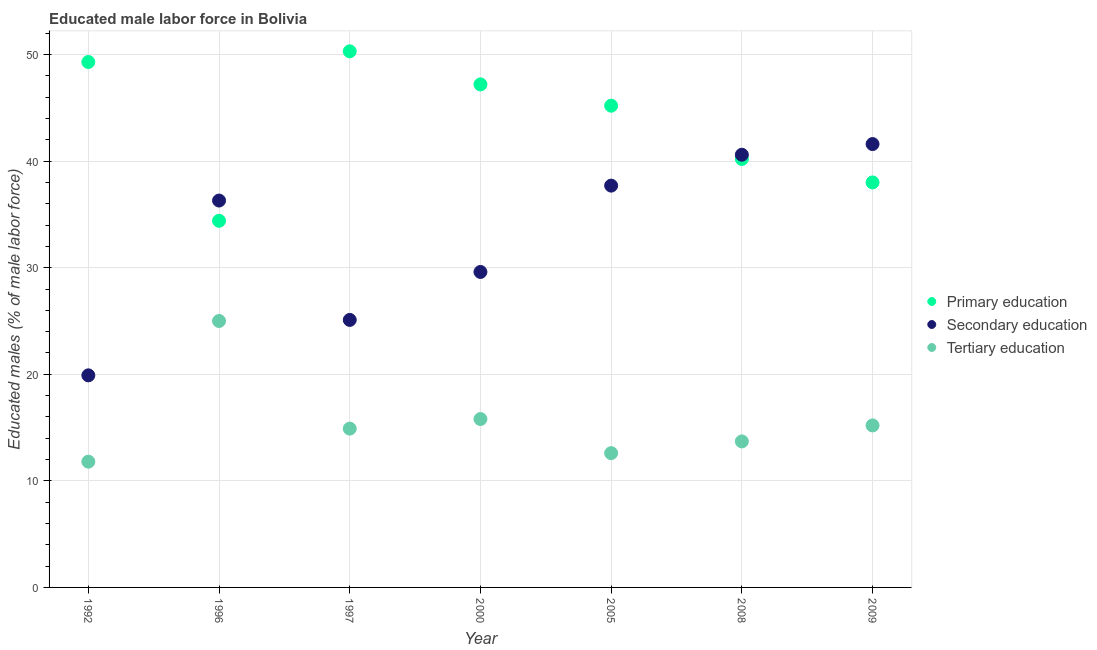How many different coloured dotlines are there?
Your answer should be very brief. 3. Is the number of dotlines equal to the number of legend labels?
Give a very brief answer. Yes. What is the percentage of male labor force who received primary education in 1992?
Your answer should be very brief. 49.3. Across all years, what is the maximum percentage of male labor force who received primary education?
Ensure brevity in your answer.  50.3. Across all years, what is the minimum percentage of male labor force who received tertiary education?
Make the answer very short. 11.8. In which year was the percentage of male labor force who received tertiary education minimum?
Offer a terse response. 1992. What is the total percentage of male labor force who received secondary education in the graph?
Provide a succinct answer. 230.8. What is the difference between the percentage of male labor force who received primary education in 1992 and that in 1996?
Give a very brief answer. 14.9. What is the difference between the percentage of male labor force who received tertiary education in 2000 and the percentage of male labor force who received primary education in 2008?
Offer a very short reply. -24.4. What is the average percentage of male labor force who received secondary education per year?
Make the answer very short. 32.97. In the year 2009, what is the difference between the percentage of male labor force who received secondary education and percentage of male labor force who received tertiary education?
Your response must be concise. 26.4. What is the ratio of the percentage of male labor force who received secondary education in 1996 to that in 2008?
Your response must be concise. 0.89. Is the percentage of male labor force who received secondary education in 1992 less than that in 2009?
Ensure brevity in your answer.  Yes. What is the difference between the highest and the second highest percentage of male labor force who received tertiary education?
Your answer should be compact. 9.2. What is the difference between the highest and the lowest percentage of male labor force who received tertiary education?
Ensure brevity in your answer.  13.2. In how many years, is the percentage of male labor force who received primary education greater than the average percentage of male labor force who received primary education taken over all years?
Give a very brief answer. 4. Is the percentage of male labor force who received primary education strictly greater than the percentage of male labor force who received secondary education over the years?
Your answer should be compact. No. Are the values on the major ticks of Y-axis written in scientific E-notation?
Offer a terse response. No. Does the graph contain any zero values?
Give a very brief answer. No. What is the title of the graph?
Give a very brief answer. Educated male labor force in Bolivia. What is the label or title of the Y-axis?
Provide a succinct answer. Educated males (% of male labor force). What is the Educated males (% of male labor force) of Primary education in 1992?
Provide a short and direct response. 49.3. What is the Educated males (% of male labor force) in Secondary education in 1992?
Offer a terse response. 19.9. What is the Educated males (% of male labor force) of Tertiary education in 1992?
Offer a terse response. 11.8. What is the Educated males (% of male labor force) of Primary education in 1996?
Your answer should be very brief. 34.4. What is the Educated males (% of male labor force) of Secondary education in 1996?
Provide a succinct answer. 36.3. What is the Educated males (% of male labor force) in Tertiary education in 1996?
Ensure brevity in your answer.  25. What is the Educated males (% of male labor force) in Primary education in 1997?
Provide a succinct answer. 50.3. What is the Educated males (% of male labor force) of Secondary education in 1997?
Give a very brief answer. 25.1. What is the Educated males (% of male labor force) in Tertiary education in 1997?
Offer a very short reply. 14.9. What is the Educated males (% of male labor force) of Primary education in 2000?
Provide a succinct answer. 47.2. What is the Educated males (% of male labor force) in Secondary education in 2000?
Make the answer very short. 29.6. What is the Educated males (% of male labor force) of Tertiary education in 2000?
Make the answer very short. 15.8. What is the Educated males (% of male labor force) in Primary education in 2005?
Give a very brief answer. 45.2. What is the Educated males (% of male labor force) of Secondary education in 2005?
Give a very brief answer. 37.7. What is the Educated males (% of male labor force) in Tertiary education in 2005?
Offer a very short reply. 12.6. What is the Educated males (% of male labor force) in Primary education in 2008?
Ensure brevity in your answer.  40.2. What is the Educated males (% of male labor force) of Secondary education in 2008?
Ensure brevity in your answer.  40.6. What is the Educated males (% of male labor force) of Tertiary education in 2008?
Your answer should be very brief. 13.7. What is the Educated males (% of male labor force) of Secondary education in 2009?
Provide a short and direct response. 41.6. What is the Educated males (% of male labor force) in Tertiary education in 2009?
Provide a short and direct response. 15.2. Across all years, what is the maximum Educated males (% of male labor force) of Primary education?
Your response must be concise. 50.3. Across all years, what is the maximum Educated males (% of male labor force) of Secondary education?
Make the answer very short. 41.6. Across all years, what is the maximum Educated males (% of male labor force) in Tertiary education?
Give a very brief answer. 25. Across all years, what is the minimum Educated males (% of male labor force) of Primary education?
Offer a very short reply. 34.4. Across all years, what is the minimum Educated males (% of male labor force) in Secondary education?
Ensure brevity in your answer.  19.9. Across all years, what is the minimum Educated males (% of male labor force) in Tertiary education?
Keep it short and to the point. 11.8. What is the total Educated males (% of male labor force) of Primary education in the graph?
Your answer should be very brief. 304.6. What is the total Educated males (% of male labor force) in Secondary education in the graph?
Offer a very short reply. 230.8. What is the total Educated males (% of male labor force) in Tertiary education in the graph?
Your answer should be very brief. 109. What is the difference between the Educated males (% of male labor force) of Secondary education in 1992 and that in 1996?
Provide a short and direct response. -16.4. What is the difference between the Educated males (% of male labor force) of Tertiary education in 1992 and that in 1996?
Make the answer very short. -13.2. What is the difference between the Educated males (% of male labor force) in Tertiary education in 1992 and that in 1997?
Give a very brief answer. -3.1. What is the difference between the Educated males (% of male labor force) in Primary education in 1992 and that in 2000?
Provide a short and direct response. 2.1. What is the difference between the Educated males (% of male labor force) in Secondary education in 1992 and that in 2000?
Provide a succinct answer. -9.7. What is the difference between the Educated males (% of male labor force) in Primary education in 1992 and that in 2005?
Your answer should be compact. 4.1. What is the difference between the Educated males (% of male labor force) of Secondary education in 1992 and that in 2005?
Provide a succinct answer. -17.8. What is the difference between the Educated males (% of male labor force) in Secondary education in 1992 and that in 2008?
Provide a succinct answer. -20.7. What is the difference between the Educated males (% of male labor force) of Secondary education in 1992 and that in 2009?
Give a very brief answer. -21.7. What is the difference between the Educated males (% of male labor force) of Tertiary education in 1992 and that in 2009?
Offer a terse response. -3.4. What is the difference between the Educated males (% of male labor force) in Primary education in 1996 and that in 1997?
Offer a terse response. -15.9. What is the difference between the Educated males (% of male labor force) in Secondary education in 1996 and that in 1997?
Offer a very short reply. 11.2. What is the difference between the Educated males (% of male labor force) of Tertiary education in 1996 and that in 1997?
Your response must be concise. 10.1. What is the difference between the Educated males (% of male labor force) of Secondary education in 1996 and that in 2000?
Make the answer very short. 6.7. What is the difference between the Educated males (% of male labor force) of Tertiary education in 1996 and that in 2000?
Provide a succinct answer. 9.2. What is the difference between the Educated males (% of male labor force) in Primary education in 1996 and that in 2005?
Offer a very short reply. -10.8. What is the difference between the Educated males (% of male labor force) in Secondary education in 1996 and that in 2005?
Provide a short and direct response. -1.4. What is the difference between the Educated males (% of male labor force) of Primary education in 1997 and that in 2000?
Give a very brief answer. 3.1. What is the difference between the Educated males (% of male labor force) in Tertiary education in 1997 and that in 2000?
Your answer should be very brief. -0.9. What is the difference between the Educated males (% of male labor force) of Primary education in 1997 and that in 2005?
Your response must be concise. 5.1. What is the difference between the Educated males (% of male labor force) of Secondary education in 1997 and that in 2005?
Your answer should be compact. -12.6. What is the difference between the Educated males (% of male labor force) in Primary education in 1997 and that in 2008?
Ensure brevity in your answer.  10.1. What is the difference between the Educated males (% of male labor force) of Secondary education in 1997 and that in 2008?
Keep it short and to the point. -15.5. What is the difference between the Educated males (% of male labor force) of Primary education in 1997 and that in 2009?
Provide a short and direct response. 12.3. What is the difference between the Educated males (% of male labor force) in Secondary education in 1997 and that in 2009?
Provide a short and direct response. -16.5. What is the difference between the Educated males (% of male labor force) of Tertiary education in 1997 and that in 2009?
Provide a succinct answer. -0.3. What is the difference between the Educated males (% of male labor force) in Secondary education in 2000 and that in 2005?
Provide a short and direct response. -8.1. What is the difference between the Educated males (% of male labor force) of Secondary education in 2000 and that in 2008?
Provide a short and direct response. -11. What is the difference between the Educated males (% of male labor force) of Tertiary education in 2000 and that in 2008?
Provide a short and direct response. 2.1. What is the difference between the Educated males (% of male labor force) of Tertiary education in 2000 and that in 2009?
Ensure brevity in your answer.  0.6. What is the difference between the Educated males (% of male labor force) of Primary education in 2005 and that in 2008?
Your answer should be very brief. 5. What is the difference between the Educated males (% of male labor force) in Secondary education in 2005 and that in 2008?
Give a very brief answer. -2.9. What is the difference between the Educated males (% of male labor force) of Primary education in 2005 and that in 2009?
Your response must be concise. 7.2. What is the difference between the Educated males (% of male labor force) of Secondary education in 2005 and that in 2009?
Provide a succinct answer. -3.9. What is the difference between the Educated males (% of male labor force) of Tertiary education in 2005 and that in 2009?
Give a very brief answer. -2.6. What is the difference between the Educated males (% of male labor force) of Primary education in 2008 and that in 2009?
Your response must be concise. 2.2. What is the difference between the Educated males (% of male labor force) of Tertiary education in 2008 and that in 2009?
Your answer should be compact. -1.5. What is the difference between the Educated males (% of male labor force) in Primary education in 1992 and the Educated males (% of male labor force) in Tertiary education in 1996?
Offer a very short reply. 24.3. What is the difference between the Educated males (% of male labor force) of Secondary education in 1992 and the Educated males (% of male labor force) of Tertiary education in 1996?
Give a very brief answer. -5.1. What is the difference between the Educated males (% of male labor force) of Primary education in 1992 and the Educated males (% of male labor force) of Secondary education in 1997?
Provide a succinct answer. 24.2. What is the difference between the Educated males (% of male labor force) in Primary education in 1992 and the Educated males (% of male labor force) in Tertiary education in 1997?
Provide a short and direct response. 34.4. What is the difference between the Educated males (% of male labor force) in Primary education in 1992 and the Educated males (% of male labor force) in Tertiary education in 2000?
Keep it short and to the point. 33.5. What is the difference between the Educated males (% of male labor force) of Secondary education in 1992 and the Educated males (% of male labor force) of Tertiary education in 2000?
Keep it short and to the point. 4.1. What is the difference between the Educated males (% of male labor force) of Primary education in 1992 and the Educated males (% of male labor force) of Tertiary education in 2005?
Keep it short and to the point. 36.7. What is the difference between the Educated males (% of male labor force) in Primary education in 1992 and the Educated males (% of male labor force) in Tertiary education in 2008?
Offer a terse response. 35.6. What is the difference between the Educated males (% of male labor force) in Primary education in 1992 and the Educated males (% of male labor force) in Secondary education in 2009?
Provide a succinct answer. 7.7. What is the difference between the Educated males (% of male labor force) of Primary education in 1992 and the Educated males (% of male labor force) of Tertiary education in 2009?
Make the answer very short. 34.1. What is the difference between the Educated males (% of male labor force) in Secondary education in 1996 and the Educated males (% of male labor force) in Tertiary education in 1997?
Your response must be concise. 21.4. What is the difference between the Educated males (% of male labor force) in Secondary education in 1996 and the Educated males (% of male labor force) in Tertiary education in 2000?
Ensure brevity in your answer.  20.5. What is the difference between the Educated males (% of male labor force) in Primary education in 1996 and the Educated males (% of male labor force) in Tertiary education in 2005?
Your response must be concise. 21.8. What is the difference between the Educated males (% of male labor force) in Secondary education in 1996 and the Educated males (% of male labor force) in Tertiary education in 2005?
Ensure brevity in your answer.  23.7. What is the difference between the Educated males (% of male labor force) of Primary education in 1996 and the Educated males (% of male labor force) of Secondary education in 2008?
Give a very brief answer. -6.2. What is the difference between the Educated males (% of male labor force) of Primary education in 1996 and the Educated males (% of male labor force) of Tertiary education in 2008?
Give a very brief answer. 20.7. What is the difference between the Educated males (% of male labor force) in Secondary education in 1996 and the Educated males (% of male labor force) in Tertiary education in 2008?
Provide a short and direct response. 22.6. What is the difference between the Educated males (% of male labor force) in Primary education in 1996 and the Educated males (% of male labor force) in Secondary education in 2009?
Your answer should be compact. -7.2. What is the difference between the Educated males (% of male labor force) of Primary education in 1996 and the Educated males (% of male labor force) of Tertiary education in 2009?
Your answer should be compact. 19.2. What is the difference between the Educated males (% of male labor force) in Secondary education in 1996 and the Educated males (% of male labor force) in Tertiary education in 2009?
Keep it short and to the point. 21.1. What is the difference between the Educated males (% of male labor force) in Primary education in 1997 and the Educated males (% of male labor force) in Secondary education in 2000?
Offer a very short reply. 20.7. What is the difference between the Educated males (% of male labor force) in Primary education in 1997 and the Educated males (% of male labor force) in Tertiary education in 2000?
Make the answer very short. 34.5. What is the difference between the Educated males (% of male labor force) in Primary education in 1997 and the Educated males (% of male labor force) in Secondary education in 2005?
Provide a short and direct response. 12.6. What is the difference between the Educated males (% of male labor force) in Primary education in 1997 and the Educated males (% of male labor force) in Tertiary education in 2005?
Make the answer very short. 37.7. What is the difference between the Educated males (% of male labor force) in Primary education in 1997 and the Educated males (% of male labor force) in Secondary education in 2008?
Make the answer very short. 9.7. What is the difference between the Educated males (% of male labor force) of Primary education in 1997 and the Educated males (% of male labor force) of Tertiary education in 2008?
Keep it short and to the point. 36.6. What is the difference between the Educated males (% of male labor force) in Primary education in 1997 and the Educated males (% of male labor force) in Secondary education in 2009?
Provide a succinct answer. 8.7. What is the difference between the Educated males (% of male labor force) of Primary education in 1997 and the Educated males (% of male labor force) of Tertiary education in 2009?
Offer a very short reply. 35.1. What is the difference between the Educated males (% of male labor force) of Secondary education in 1997 and the Educated males (% of male labor force) of Tertiary education in 2009?
Make the answer very short. 9.9. What is the difference between the Educated males (% of male labor force) of Primary education in 2000 and the Educated males (% of male labor force) of Secondary education in 2005?
Provide a short and direct response. 9.5. What is the difference between the Educated males (% of male labor force) of Primary education in 2000 and the Educated males (% of male labor force) of Tertiary education in 2005?
Your response must be concise. 34.6. What is the difference between the Educated males (% of male labor force) of Secondary education in 2000 and the Educated males (% of male labor force) of Tertiary education in 2005?
Offer a very short reply. 17. What is the difference between the Educated males (% of male labor force) of Primary education in 2000 and the Educated males (% of male labor force) of Secondary education in 2008?
Ensure brevity in your answer.  6.6. What is the difference between the Educated males (% of male labor force) of Primary education in 2000 and the Educated males (% of male labor force) of Tertiary education in 2008?
Your answer should be compact. 33.5. What is the difference between the Educated males (% of male labor force) in Secondary education in 2000 and the Educated males (% of male labor force) in Tertiary education in 2008?
Keep it short and to the point. 15.9. What is the difference between the Educated males (% of male labor force) of Primary education in 2000 and the Educated males (% of male labor force) of Secondary education in 2009?
Provide a succinct answer. 5.6. What is the difference between the Educated males (% of male labor force) of Secondary education in 2000 and the Educated males (% of male labor force) of Tertiary education in 2009?
Make the answer very short. 14.4. What is the difference between the Educated males (% of male labor force) in Primary education in 2005 and the Educated males (% of male labor force) in Secondary education in 2008?
Make the answer very short. 4.6. What is the difference between the Educated males (% of male labor force) of Primary education in 2005 and the Educated males (% of male labor force) of Tertiary education in 2008?
Your answer should be compact. 31.5. What is the difference between the Educated males (% of male labor force) in Secondary education in 2005 and the Educated males (% of male labor force) in Tertiary education in 2009?
Your response must be concise. 22.5. What is the difference between the Educated males (% of male labor force) in Primary education in 2008 and the Educated males (% of male labor force) in Tertiary education in 2009?
Your answer should be very brief. 25. What is the difference between the Educated males (% of male labor force) in Secondary education in 2008 and the Educated males (% of male labor force) in Tertiary education in 2009?
Provide a succinct answer. 25.4. What is the average Educated males (% of male labor force) of Primary education per year?
Provide a succinct answer. 43.51. What is the average Educated males (% of male labor force) in Secondary education per year?
Keep it short and to the point. 32.97. What is the average Educated males (% of male labor force) in Tertiary education per year?
Your response must be concise. 15.57. In the year 1992, what is the difference between the Educated males (% of male labor force) in Primary education and Educated males (% of male labor force) in Secondary education?
Your answer should be compact. 29.4. In the year 1992, what is the difference between the Educated males (% of male labor force) in Primary education and Educated males (% of male labor force) in Tertiary education?
Offer a very short reply. 37.5. In the year 1996, what is the difference between the Educated males (% of male labor force) in Primary education and Educated males (% of male labor force) in Secondary education?
Offer a terse response. -1.9. In the year 1997, what is the difference between the Educated males (% of male labor force) in Primary education and Educated males (% of male labor force) in Secondary education?
Offer a terse response. 25.2. In the year 1997, what is the difference between the Educated males (% of male labor force) of Primary education and Educated males (% of male labor force) of Tertiary education?
Your answer should be very brief. 35.4. In the year 2000, what is the difference between the Educated males (% of male labor force) in Primary education and Educated males (% of male labor force) in Tertiary education?
Give a very brief answer. 31.4. In the year 2005, what is the difference between the Educated males (% of male labor force) in Primary education and Educated males (% of male labor force) in Secondary education?
Offer a terse response. 7.5. In the year 2005, what is the difference between the Educated males (% of male labor force) of Primary education and Educated males (% of male labor force) of Tertiary education?
Make the answer very short. 32.6. In the year 2005, what is the difference between the Educated males (% of male labor force) in Secondary education and Educated males (% of male labor force) in Tertiary education?
Your answer should be very brief. 25.1. In the year 2008, what is the difference between the Educated males (% of male labor force) in Secondary education and Educated males (% of male labor force) in Tertiary education?
Your answer should be compact. 26.9. In the year 2009, what is the difference between the Educated males (% of male labor force) in Primary education and Educated males (% of male labor force) in Tertiary education?
Give a very brief answer. 22.8. In the year 2009, what is the difference between the Educated males (% of male labor force) in Secondary education and Educated males (% of male labor force) in Tertiary education?
Your answer should be very brief. 26.4. What is the ratio of the Educated males (% of male labor force) of Primary education in 1992 to that in 1996?
Your answer should be very brief. 1.43. What is the ratio of the Educated males (% of male labor force) in Secondary education in 1992 to that in 1996?
Offer a very short reply. 0.55. What is the ratio of the Educated males (% of male labor force) of Tertiary education in 1992 to that in 1996?
Provide a short and direct response. 0.47. What is the ratio of the Educated males (% of male labor force) in Primary education in 1992 to that in 1997?
Your answer should be very brief. 0.98. What is the ratio of the Educated males (% of male labor force) of Secondary education in 1992 to that in 1997?
Provide a succinct answer. 0.79. What is the ratio of the Educated males (% of male labor force) of Tertiary education in 1992 to that in 1997?
Keep it short and to the point. 0.79. What is the ratio of the Educated males (% of male labor force) of Primary education in 1992 to that in 2000?
Provide a short and direct response. 1.04. What is the ratio of the Educated males (% of male labor force) of Secondary education in 1992 to that in 2000?
Your response must be concise. 0.67. What is the ratio of the Educated males (% of male labor force) in Tertiary education in 1992 to that in 2000?
Your response must be concise. 0.75. What is the ratio of the Educated males (% of male labor force) of Primary education in 1992 to that in 2005?
Ensure brevity in your answer.  1.09. What is the ratio of the Educated males (% of male labor force) of Secondary education in 1992 to that in 2005?
Your answer should be compact. 0.53. What is the ratio of the Educated males (% of male labor force) in Tertiary education in 1992 to that in 2005?
Make the answer very short. 0.94. What is the ratio of the Educated males (% of male labor force) of Primary education in 1992 to that in 2008?
Offer a terse response. 1.23. What is the ratio of the Educated males (% of male labor force) of Secondary education in 1992 to that in 2008?
Your answer should be very brief. 0.49. What is the ratio of the Educated males (% of male labor force) of Tertiary education in 1992 to that in 2008?
Provide a short and direct response. 0.86. What is the ratio of the Educated males (% of male labor force) of Primary education in 1992 to that in 2009?
Your response must be concise. 1.3. What is the ratio of the Educated males (% of male labor force) in Secondary education in 1992 to that in 2009?
Give a very brief answer. 0.48. What is the ratio of the Educated males (% of male labor force) of Tertiary education in 1992 to that in 2009?
Offer a very short reply. 0.78. What is the ratio of the Educated males (% of male labor force) in Primary education in 1996 to that in 1997?
Give a very brief answer. 0.68. What is the ratio of the Educated males (% of male labor force) in Secondary education in 1996 to that in 1997?
Your answer should be compact. 1.45. What is the ratio of the Educated males (% of male labor force) in Tertiary education in 1996 to that in 1997?
Provide a succinct answer. 1.68. What is the ratio of the Educated males (% of male labor force) of Primary education in 1996 to that in 2000?
Your response must be concise. 0.73. What is the ratio of the Educated males (% of male labor force) in Secondary education in 1996 to that in 2000?
Provide a short and direct response. 1.23. What is the ratio of the Educated males (% of male labor force) of Tertiary education in 1996 to that in 2000?
Offer a terse response. 1.58. What is the ratio of the Educated males (% of male labor force) in Primary education in 1996 to that in 2005?
Keep it short and to the point. 0.76. What is the ratio of the Educated males (% of male labor force) in Secondary education in 1996 to that in 2005?
Offer a terse response. 0.96. What is the ratio of the Educated males (% of male labor force) in Tertiary education in 1996 to that in 2005?
Provide a succinct answer. 1.98. What is the ratio of the Educated males (% of male labor force) in Primary education in 1996 to that in 2008?
Offer a terse response. 0.86. What is the ratio of the Educated males (% of male labor force) in Secondary education in 1996 to that in 2008?
Provide a succinct answer. 0.89. What is the ratio of the Educated males (% of male labor force) of Tertiary education in 1996 to that in 2008?
Your response must be concise. 1.82. What is the ratio of the Educated males (% of male labor force) of Primary education in 1996 to that in 2009?
Offer a terse response. 0.91. What is the ratio of the Educated males (% of male labor force) in Secondary education in 1996 to that in 2009?
Give a very brief answer. 0.87. What is the ratio of the Educated males (% of male labor force) in Tertiary education in 1996 to that in 2009?
Provide a short and direct response. 1.64. What is the ratio of the Educated males (% of male labor force) in Primary education in 1997 to that in 2000?
Provide a short and direct response. 1.07. What is the ratio of the Educated males (% of male labor force) in Secondary education in 1997 to that in 2000?
Your response must be concise. 0.85. What is the ratio of the Educated males (% of male labor force) of Tertiary education in 1997 to that in 2000?
Provide a short and direct response. 0.94. What is the ratio of the Educated males (% of male labor force) in Primary education in 1997 to that in 2005?
Your answer should be compact. 1.11. What is the ratio of the Educated males (% of male labor force) of Secondary education in 1997 to that in 2005?
Keep it short and to the point. 0.67. What is the ratio of the Educated males (% of male labor force) of Tertiary education in 1997 to that in 2005?
Your answer should be very brief. 1.18. What is the ratio of the Educated males (% of male labor force) in Primary education in 1997 to that in 2008?
Give a very brief answer. 1.25. What is the ratio of the Educated males (% of male labor force) of Secondary education in 1997 to that in 2008?
Offer a very short reply. 0.62. What is the ratio of the Educated males (% of male labor force) of Tertiary education in 1997 to that in 2008?
Ensure brevity in your answer.  1.09. What is the ratio of the Educated males (% of male labor force) of Primary education in 1997 to that in 2009?
Offer a very short reply. 1.32. What is the ratio of the Educated males (% of male labor force) in Secondary education in 1997 to that in 2009?
Your response must be concise. 0.6. What is the ratio of the Educated males (% of male labor force) of Tertiary education in 1997 to that in 2009?
Offer a terse response. 0.98. What is the ratio of the Educated males (% of male labor force) in Primary education in 2000 to that in 2005?
Ensure brevity in your answer.  1.04. What is the ratio of the Educated males (% of male labor force) in Secondary education in 2000 to that in 2005?
Your answer should be very brief. 0.79. What is the ratio of the Educated males (% of male labor force) in Tertiary education in 2000 to that in 2005?
Offer a very short reply. 1.25. What is the ratio of the Educated males (% of male labor force) in Primary education in 2000 to that in 2008?
Provide a succinct answer. 1.17. What is the ratio of the Educated males (% of male labor force) in Secondary education in 2000 to that in 2008?
Your answer should be very brief. 0.73. What is the ratio of the Educated males (% of male labor force) of Tertiary education in 2000 to that in 2008?
Offer a terse response. 1.15. What is the ratio of the Educated males (% of male labor force) in Primary education in 2000 to that in 2009?
Your response must be concise. 1.24. What is the ratio of the Educated males (% of male labor force) in Secondary education in 2000 to that in 2009?
Provide a short and direct response. 0.71. What is the ratio of the Educated males (% of male labor force) in Tertiary education in 2000 to that in 2009?
Provide a succinct answer. 1.04. What is the ratio of the Educated males (% of male labor force) of Primary education in 2005 to that in 2008?
Give a very brief answer. 1.12. What is the ratio of the Educated males (% of male labor force) of Tertiary education in 2005 to that in 2008?
Give a very brief answer. 0.92. What is the ratio of the Educated males (% of male labor force) of Primary education in 2005 to that in 2009?
Keep it short and to the point. 1.19. What is the ratio of the Educated males (% of male labor force) in Secondary education in 2005 to that in 2009?
Offer a terse response. 0.91. What is the ratio of the Educated males (% of male labor force) of Tertiary education in 2005 to that in 2009?
Your answer should be compact. 0.83. What is the ratio of the Educated males (% of male labor force) in Primary education in 2008 to that in 2009?
Give a very brief answer. 1.06. What is the ratio of the Educated males (% of male labor force) in Tertiary education in 2008 to that in 2009?
Provide a succinct answer. 0.9. What is the difference between the highest and the lowest Educated males (% of male labor force) of Primary education?
Your answer should be very brief. 15.9. What is the difference between the highest and the lowest Educated males (% of male labor force) of Secondary education?
Provide a succinct answer. 21.7. What is the difference between the highest and the lowest Educated males (% of male labor force) of Tertiary education?
Your response must be concise. 13.2. 